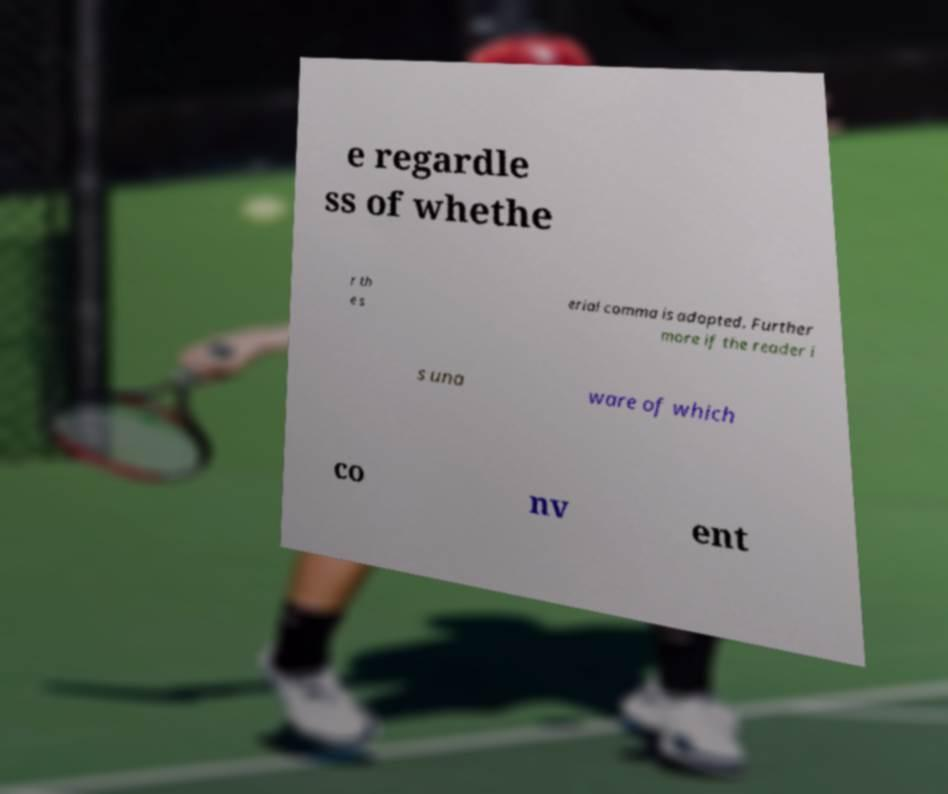For documentation purposes, I need the text within this image transcribed. Could you provide that? e regardle ss of whethe r th e s erial comma is adopted. Further more if the reader i s una ware of which co nv ent 